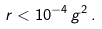<formula> <loc_0><loc_0><loc_500><loc_500>r < 1 0 ^ { - 4 } \, g ^ { 2 } \, .</formula> 